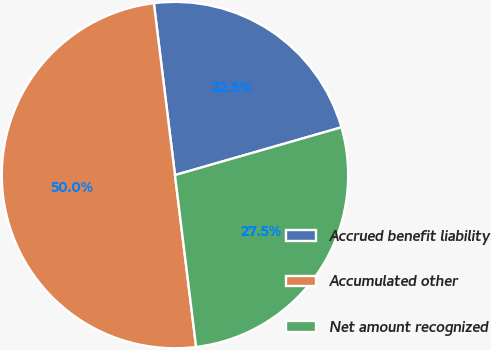<chart> <loc_0><loc_0><loc_500><loc_500><pie_chart><fcel>Accrued benefit liability<fcel>Accumulated other<fcel>Net amount recognized<nl><fcel>22.5%<fcel>50.0%<fcel>27.5%<nl></chart> 